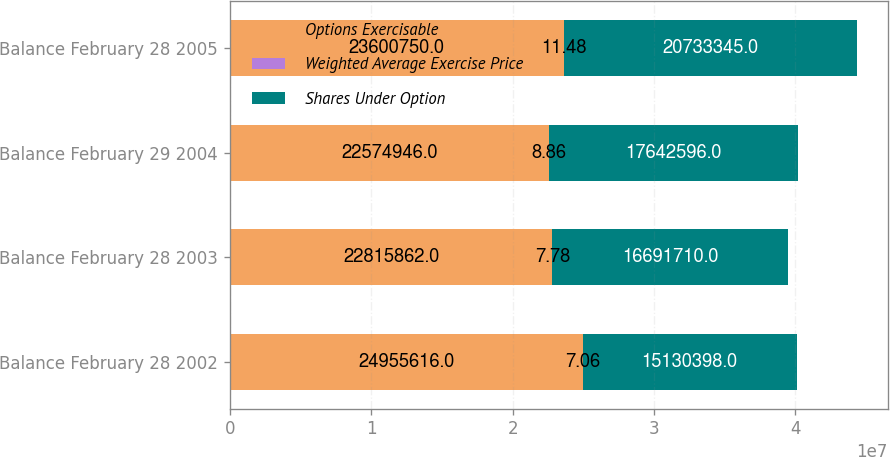Convert chart. <chart><loc_0><loc_0><loc_500><loc_500><stacked_bar_chart><ecel><fcel>Balance February 28 2002<fcel>Balance February 28 2003<fcel>Balance February 29 2004<fcel>Balance February 28 2005<nl><fcel>Options Exercisable<fcel>2.49556e+07<fcel>2.28159e+07<fcel>2.25749e+07<fcel>2.36008e+07<nl><fcel>Weighted Average Exercise Price<fcel>7.06<fcel>7.78<fcel>8.86<fcel>11.48<nl><fcel>Shares Under Option<fcel>1.51304e+07<fcel>1.66917e+07<fcel>1.76426e+07<fcel>2.07333e+07<nl></chart> 